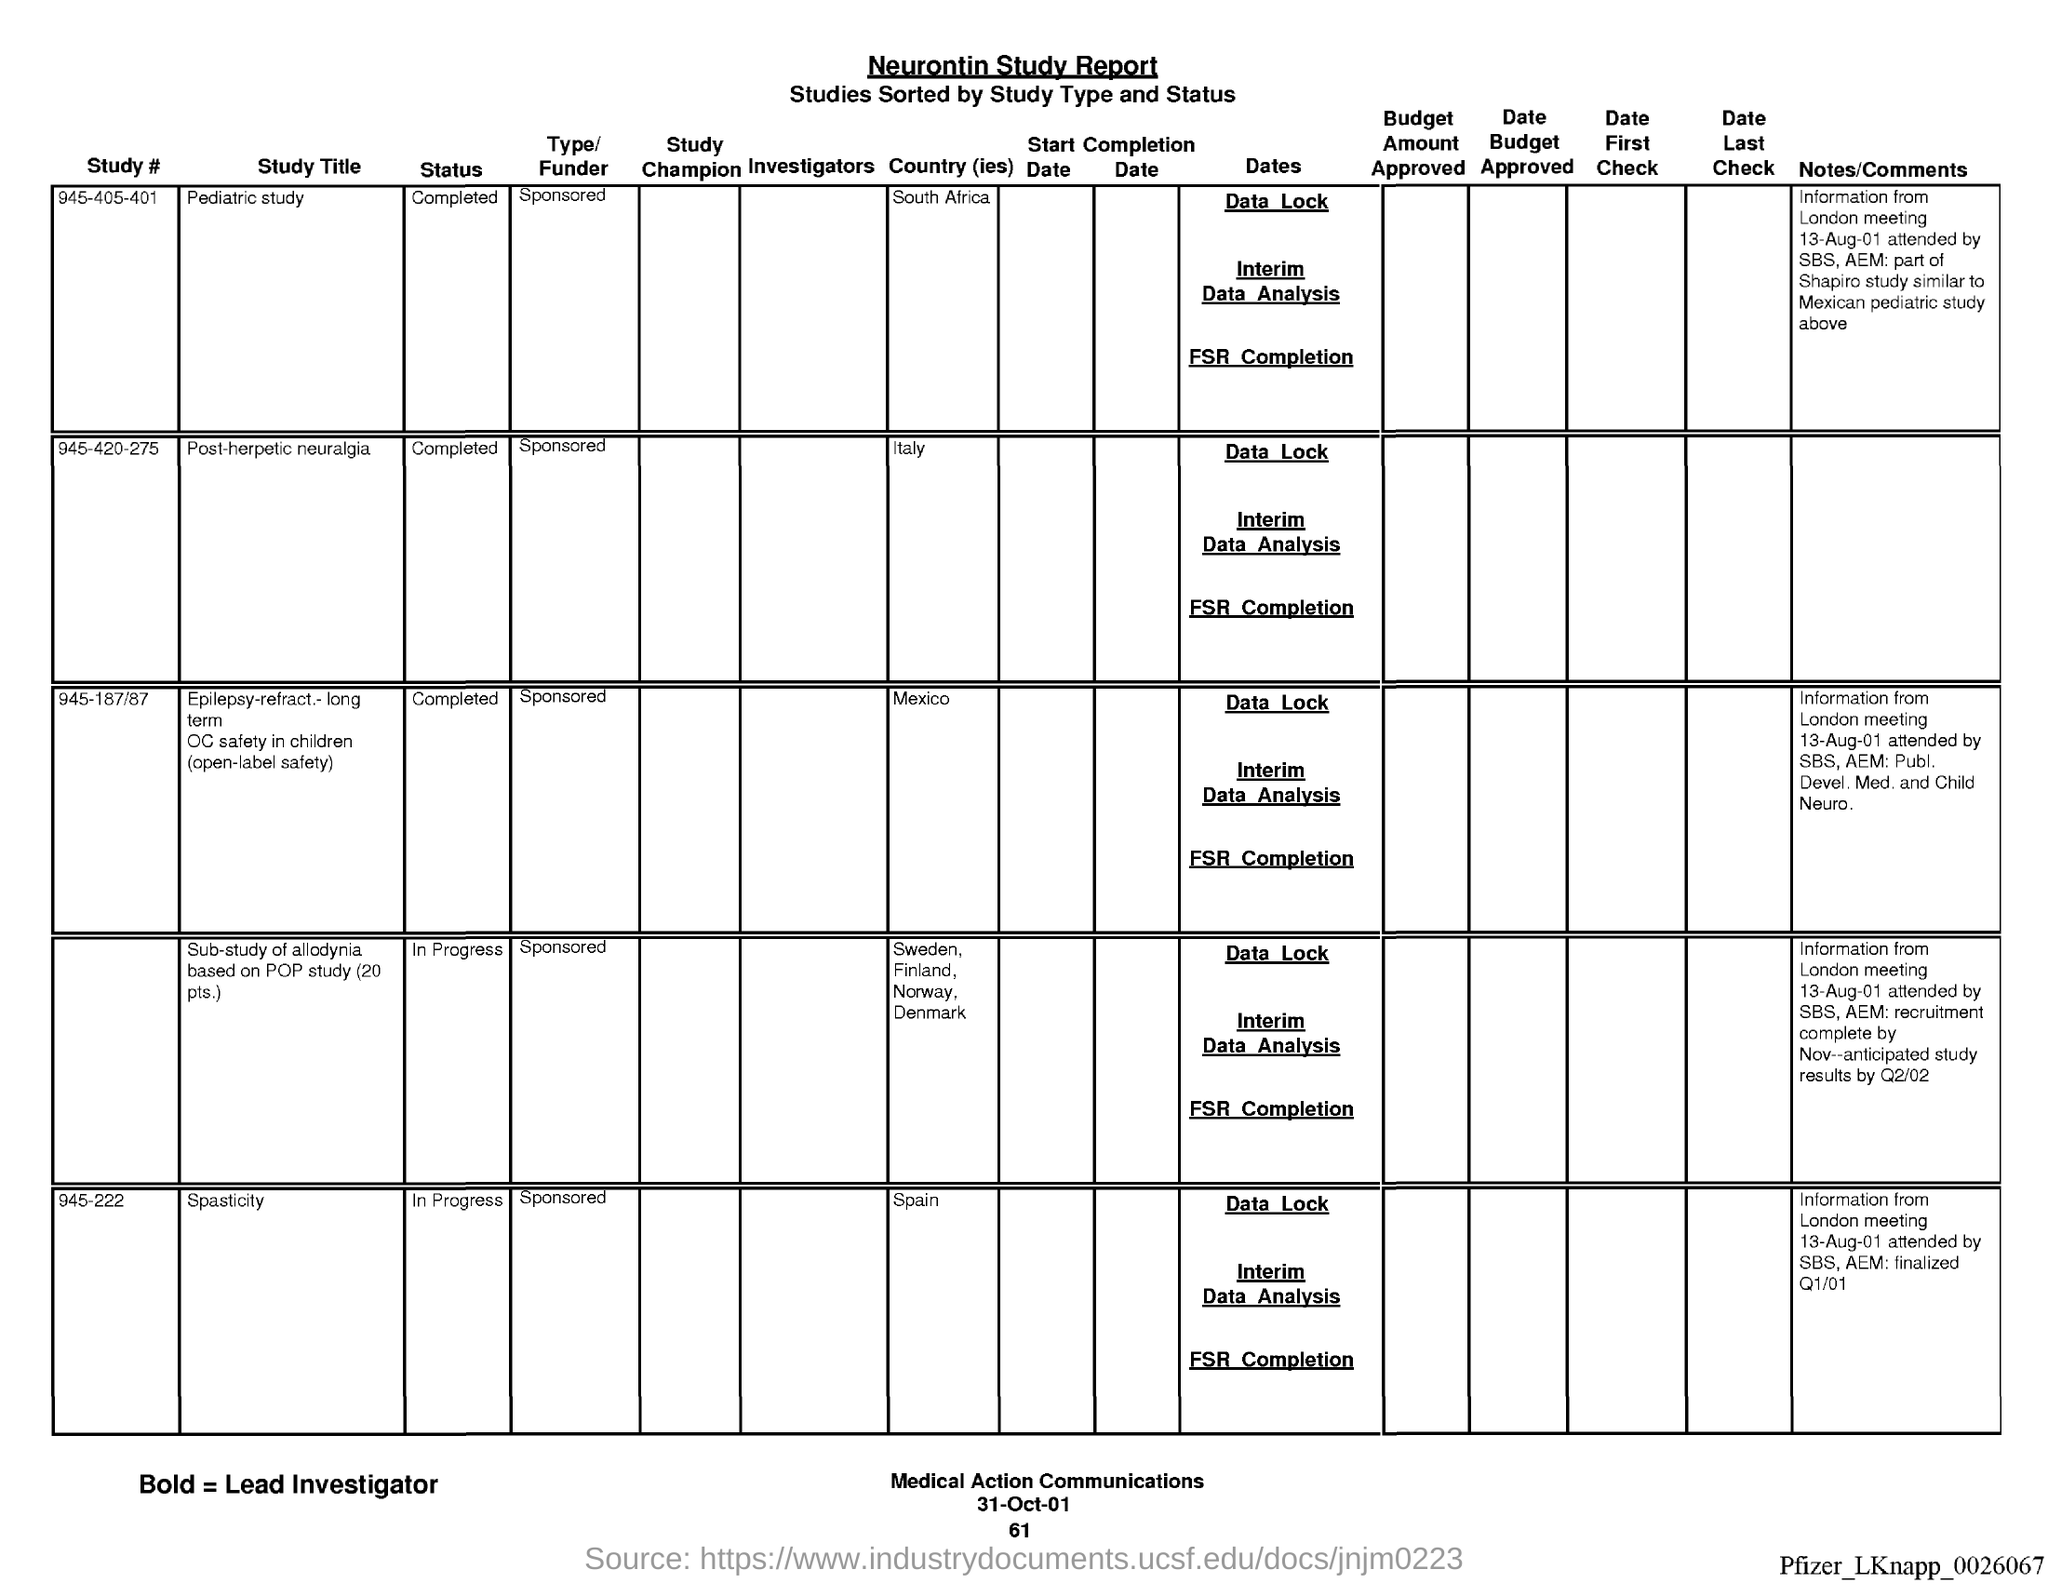Mention a couple of crucial points in this snapshot. On the bottom of the page, the date "31-Oct-01" can be found. The name of the report is the Neurontin study report. The question "what is the page number below date?" is asking for information about a specific page number that is associated with a particular date. The speaker is requesting information about the page number that is located below a specific date. 